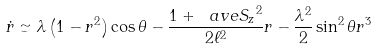<formula> <loc_0><loc_0><loc_500><loc_500>\dot { r } \simeq \lambda \left ( 1 - r ^ { 2 } \right ) \cos \theta - \frac { 1 + \ a v e { S _ { z } } ^ { 2 } } { 2 \ell ^ { 2 } } r - \frac { \lambda ^ { 2 } } { 2 } \sin ^ { 2 } \theta r ^ { 3 }</formula> 